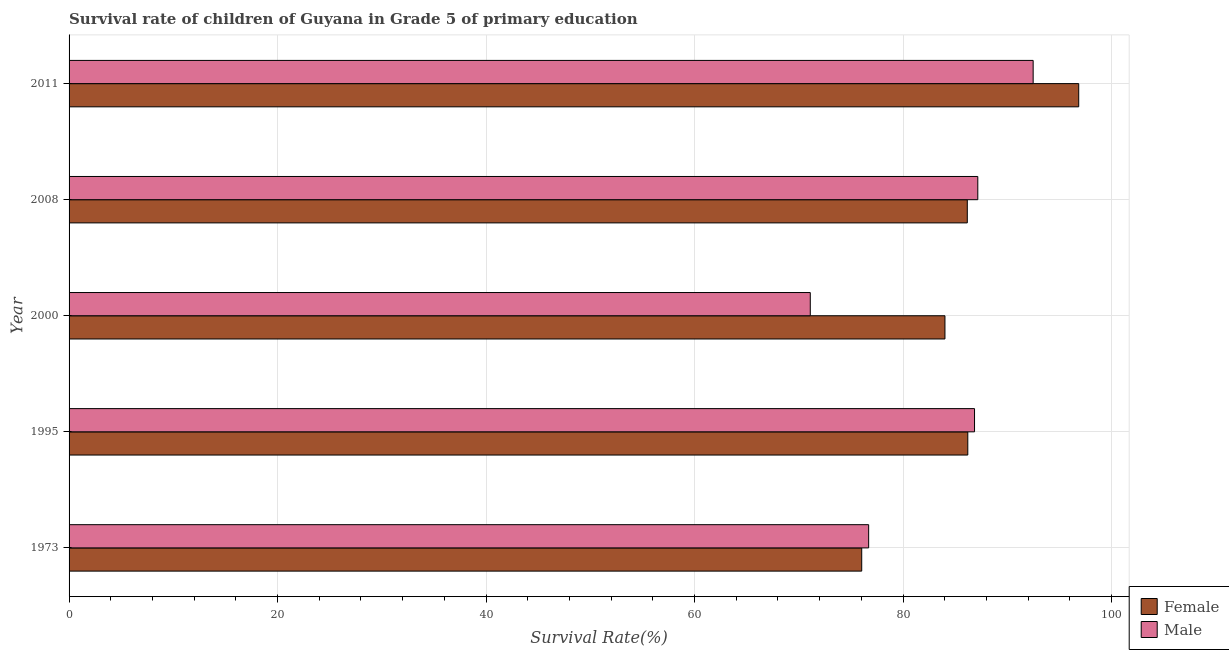How many bars are there on the 1st tick from the top?
Ensure brevity in your answer.  2. What is the label of the 4th group of bars from the top?
Make the answer very short. 1995. What is the survival rate of female students in primary education in 2000?
Make the answer very short. 84.02. Across all years, what is the maximum survival rate of male students in primary education?
Provide a succinct answer. 92.49. Across all years, what is the minimum survival rate of female students in primary education?
Ensure brevity in your answer.  76.04. In which year was the survival rate of male students in primary education minimum?
Offer a very short reply. 2000. What is the total survival rate of female students in primary education in the graph?
Keep it short and to the point. 429.3. What is the difference between the survival rate of male students in primary education in 1973 and that in 2000?
Your answer should be very brief. 5.6. What is the difference between the survival rate of female students in primary education in 1973 and the survival rate of male students in primary education in 2008?
Ensure brevity in your answer.  -11.14. What is the average survival rate of male students in primary education per year?
Your response must be concise. 82.87. In the year 2000, what is the difference between the survival rate of female students in primary education and survival rate of male students in primary education?
Give a very brief answer. 12.92. What is the ratio of the survival rate of male students in primary education in 1995 to that in 2000?
Give a very brief answer. 1.22. What is the difference between the highest and the second highest survival rate of female students in primary education?
Keep it short and to the point. 10.64. What is the difference between the highest and the lowest survival rate of male students in primary education?
Provide a short and direct response. 21.38. Is the sum of the survival rate of female students in primary education in 1973 and 1995 greater than the maximum survival rate of male students in primary education across all years?
Ensure brevity in your answer.  Yes. What does the 2nd bar from the top in 2008 represents?
Keep it short and to the point. Female. What does the 2nd bar from the bottom in 1973 represents?
Make the answer very short. Male. Are the values on the major ticks of X-axis written in scientific E-notation?
Your response must be concise. No. Does the graph contain any zero values?
Make the answer very short. No. Does the graph contain grids?
Ensure brevity in your answer.  Yes. Where does the legend appear in the graph?
Provide a short and direct response. Bottom right. How many legend labels are there?
Your answer should be compact. 2. What is the title of the graph?
Offer a terse response. Survival rate of children of Guyana in Grade 5 of primary education. What is the label or title of the X-axis?
Ensure brevity in your answer.  Survival Rate(%). What is the label or title of the Y-axis?
Your response must be concise. Year. What is the Survival Rate(%) in Female in 1973?
Make the answer very short. 76.04. What is the Survival Rate(%) in Male in 1973?
Your response must be concise. 76.7. What is the Survival Rate(%) of Female in 1995?
Your response must be concise. 86.21. What is the Survival Rate(%) of Male in 1995?
Provide a succinct answer. 86.86. What is the Survival Rate(%) in Female in 2000?
Provide a short and direct response. 84.02. What is the Survival Rate(%) in Male in 2000?
Give a very brief answer. 71.1. What is the Survival Rate(%) in Female in 2008?
Offer a very short reply. 86.17. What is the Survival Rate(%) in Male in 2008?
Your answer should be very brief. 87.17. What is the Survival Rate(%) of Female in 2011?
Your response must be concise. 96.85. What is the Survival Rate(%) of Male in 2011?
Keep it short and to the point. 92.49. Across all years, what is the maximum Survival Rate(%) of Female?
Offer a terse response. 96.85. Across all years, what is the maximum Survival Rate(%) of Male?
Offer a very short reply. 92.49. Across all years, what is the minimum Survival Rate(%) in Female?
Your answer should be compact. 76.04. Across all years, what is the minimum Survival Rate(%) of Male?
Provide a short and direct response. 71.1. What is the total Survival Rate(%) of Female in the graph?
Keep it short and to the point. 429.3. What is the total Survival Rate(%) in Male in the graph?
Provide a short and direct response. 414.33. What is the difference between the Survival Rate(%) in Female in 1973 and that in 1995?
Your answer should be very brief. -10.18. What is the difference between the Survival Rate(%) in Male in 1973 and that in 1995?
Ensure brevity in your answer.  -10.16. What is the difference between the Survival Rate(%) of Female in 1973 and that in 2000?
Provide a short and direct response. -7.99. What is the difference between the Survival Rate(%) of Male in 1973 and that in 2000?
Ensure brevity in your answer.  5.6. What is the difference between the Survival Rate(%) of Female in 1973 and that in 2008?
Your answer should be compact. -10.13. What is the difference between the Survival Rate(%) in Male in 1973 and that in 2008?
Ensure brevity in your answer.  -10.47. What is the difference between the Survival Rate(%) in Female in 1973 and that in 2011?
Give a very brief answer. -20.82. What is the difference between the Survival Rate(%) in Male in 1973 and that in 2011?
Offer a very short reply. -15.78. What is the difference between the Survival Rate(%) of Female in 1995 and that in 2000?
Provide a short and direct response. 2.19. What is the difference between the Survival Rate(%) of Male in 1995 and that in 2000?
Offer a very short reply. 15.76. What is the difference between the Survival Rate(%) of Female in 1995 and that in 2008?
Your answer should be compact. 0.05. What is the difference between the Survival Rate(%) of Male in 1995 and that in 2008?
Offer a terse response. -0.31. What is the difference between the Survival Rate(%) of Female in 1995 and that in 2011?
Make the answer very short. -10.64. What is the difference between the Survival Rate(%) of Male in 1995 and that in 2011?
Keep it short and to the point. -5.62. What is the difference between the Survival Rate(%) of Female in 2000 and that in 2008?
Keep it short and to the point. -2.14. What is the difference between the Survival Rate(%) in Male in 2000 and that in 2008?
Your answer should be very brief. -16.07. What is the difference between the Survival Rate(%) in Female in 2000 and that in 2011?
Keep it short and to the point. -12.83. What is the difference between the Survival Rate(%) in Male in 2000 and that in 2011?
Your answer should be compact. -21.38. What is the difference between the Survival Rate(%) in Female in 2008 and that in 2011?
Offer a terse response. -10.69. What is the difference between the Survival Rate(%) in Male in 2008 and that in 2011?
Your answer should be very brief. -5.31. What is the difference between the Survival Rate(%) of Female in 1973 and the Survival Rate(%) of Male in 1995?
Keep it short and to the point. -10.82. What is the difference between the Survival Rate(%) of Female in 1973 and the Survival Rate(%) of Male in 2000?
Your response must be concise. 4.93. What is the difference between the Survival Rate(%) of Female in 1973 and the Survival Rate(%) of Male in 2008?
Make the answer very short. -11.14. What is the difference between the Survival Rate(%) of Female in 1973 and the Survival Rate(%) of Male in 2011?
Your answer should be compact. -16.45. What is the difference between the Survival Rate(%) in Female in 1995 and the Survival Rate(%) in Male in 2000?
Your answer should be compact. 15.11. What is the difference between the Survival Rate(%) of Female in 1995 and the Survival Rate(%) of Male in 2008?
Offer a terse response. -0.96. What is the difference between the Survival Rate(%) of Female in 1995 and the Survival Rate(%) of Male in 2011?
Make the answer very short. -6.27. What is the difference between the Survival Rate(%) in Female in 2000 and the Survival Rate(%) in Male in 2008?
Keep it short and to the point. -3.15. What is the difference between the Survival Rate(%) of Female in 2000 and the Survival Rate(%) of Male in 2011?
Your response must be concise. -8.46. What is the difference between the Survival Rate(%) in Female in 2008 and the Survival Rate(%) in Male in 2011?
Your response must be concise. -6.32. What is the average Survival Rate(%) in Female per year?
Keep it short and to the point. 85.86. What is the average Survival Rate(%) in Male per year?
Offer a very short reply. 82.87. In the year 1973, what is the difference between the Survival Rate(%) in Female and Survival Rate(%) in Male?
Your response must be concise. -0.67. In the year 1995, what is the difference between the Survival Rate(%) in Female and Survival Rate(%) in Male?
Keep it short and to the point. -0.65. In the year 2000, what is the difference between the Survival Rate(%) in Female and Survival Rate(%) in Male?
Ensure brevity in your answer.  12.92. In the year 2008, what is the difference between the Survival Rate(%) in Female and Survival Rate(%) in Male?
Your answer should be very brief. -1.01. In the year 2011, what is the difference between the Survival Rate(%) of Female and Survival Rate(%) of Male?
Provide a succinct answer. 4.37. What is the ratio of the Survival Rate(%) in Female in 1973 to that in 1995?
Keep it short and to the point. 0.88. What is the ratio of the Survival Rate(%) in Male in 1973 to that in 1995?
Your answer should be compact. 0.88. What is the ratio of the Survival Rate(%) of Female in 1973 to that in 2000?
Offer a very short reply. 0.91. What is the ratio of the Survival Rate(%) of Male in 1973 to that in 2000?
Make the answer very short. 1.08. What is the ratio of the Survival Rate(%) of Female in 1973 to that in 2008?
Provide a succinct answer. 0.88. What is the ratio of the Survival Rate(%) in Male in 1973 to that in 2008?
Provide a short and direct response. 0.88. What is the ratio of the Survival Rate(%) of Female in 1973 to that in 2011?
Give a very brief answer. 0.79. What is the ratio of the Survival Rate(%) of Male in 1973 to that in 2011?
Make the answer very short. 0.83. What is the ratio of the Survival Rate(%) in Female in 1995 to that in 2000?
Make the answer very short. 1.03. What is the ratio of the Survival Rate(%) in Male in 1995 to that in 2000?
Ensure brevity in your answer.  1.22. What is the ratio of the Survival Rate(%) of Male in 1995 to that in 2008?
Your answer should be very brief. 1. What is the ratio of the Survival Rate(%) of Female in 1995 to that in 2011?
Your answer should be compact. 0.89. What is the ratio of the Survival Rate(%) of Male in 1995 to that in 2011?
Ensure brevity in your answer.  0.94. What is the ratio of the Survival Rate(%) of Female in 2000 to that in 2008?
Offer a terse response. 0.98. What is the ratio of the Survival Rate(%) in Male in 2000 to that in 2008?
Give a very brief answer. 0.82. What is the ratio of the Survival Rate(%) in Female in 2000 to that in 2011?
Make the answer very short. 0.87. What is the ratio of the Survival Rate(%) of Male in 2000 to that in 2011?
Ensure brevity in your answer.  0.77. What is the ratio of the Survival Rate(%) in Female in 2008 to that in 2011?
Make the answer very short. 0.89. What is the ratio of the Survival Rate(%) in Male in 2008 to that in 2011?
Offer a very short reply. 0.94. What is the difference between the highest and the second highest Survival Rate(%) in Female?
Your response must be concise. 10.64. What is the difference between the highest and the second highest Survival Rate(%) in Male?
Keep it short and to the point. 5.31. What is the difference between the highest and the lowest Survival Rate(%) of Female?
Ensure brevity in your answer.  20.82. What is the difference between the highest and the lowest Survival Rate(%) of Male?
Your answer should be compact. 21.38. 